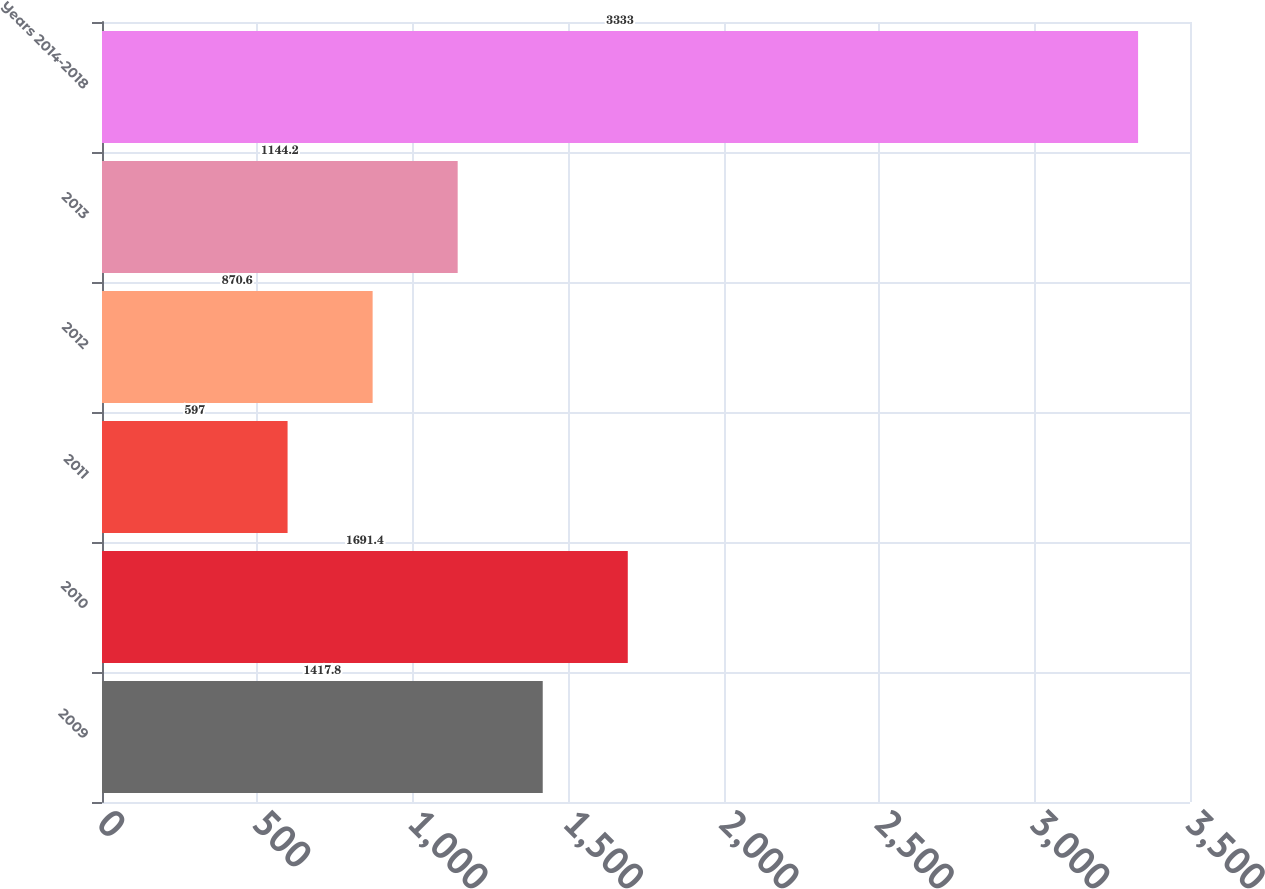Convert chart. <chart><loc_0><loc_0><loc_500><loc_500><bar_chart><fcel>2009<fcel>2010<fcel>2011<fcel>2012<fcel>2013<fcel>Years 2014-2018<nl><fcel>1417.8<fcel>1691.4<fcel>597<fcel>870.6<fcel>1144.2<fcel>3333<nl></chart> 